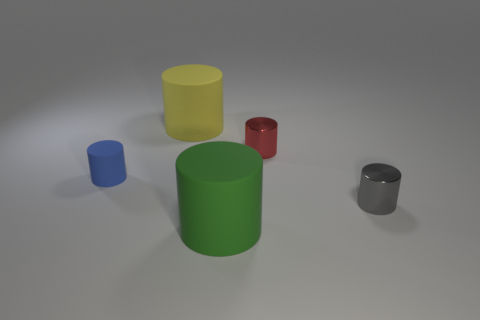How many gray shiny objects are there?
Your answer should be very brief. 1. How many objects are to the left of the small red thing and behind the small gray metal cylinder?
Offer a terse response. 2. What is the tiny gray cylinder made of?
Provide a succinct answer. Metal. Is there a small metallic object?
Your answer should be compact. Yes. What is the color of the big cylinder that is in front of the red cylinder?
Your answer should be very brief. Green. How many blue cylinders are right of the metallic thing that is on the left side of the tiny object that is to the right of the red thing?
Your response must be concise. 0. What material is the small object that is both in front of the red cylinder and to the right of the large green object?
Ensure brevity in your answer.  Metal. Is the big yellow thing made of the same material as the tiny cylinder on the left side of the yellow rubber cylinder?
Ensure brevity in your answer.  Yes. Are there more small shiny cylinders in front of the gray cylinder than large matte cylinders that are in front of the tiny rubber object?
Make the answer very short. No. The green matte thing is what shape?
Keep it short and to the point. Cylinder. 